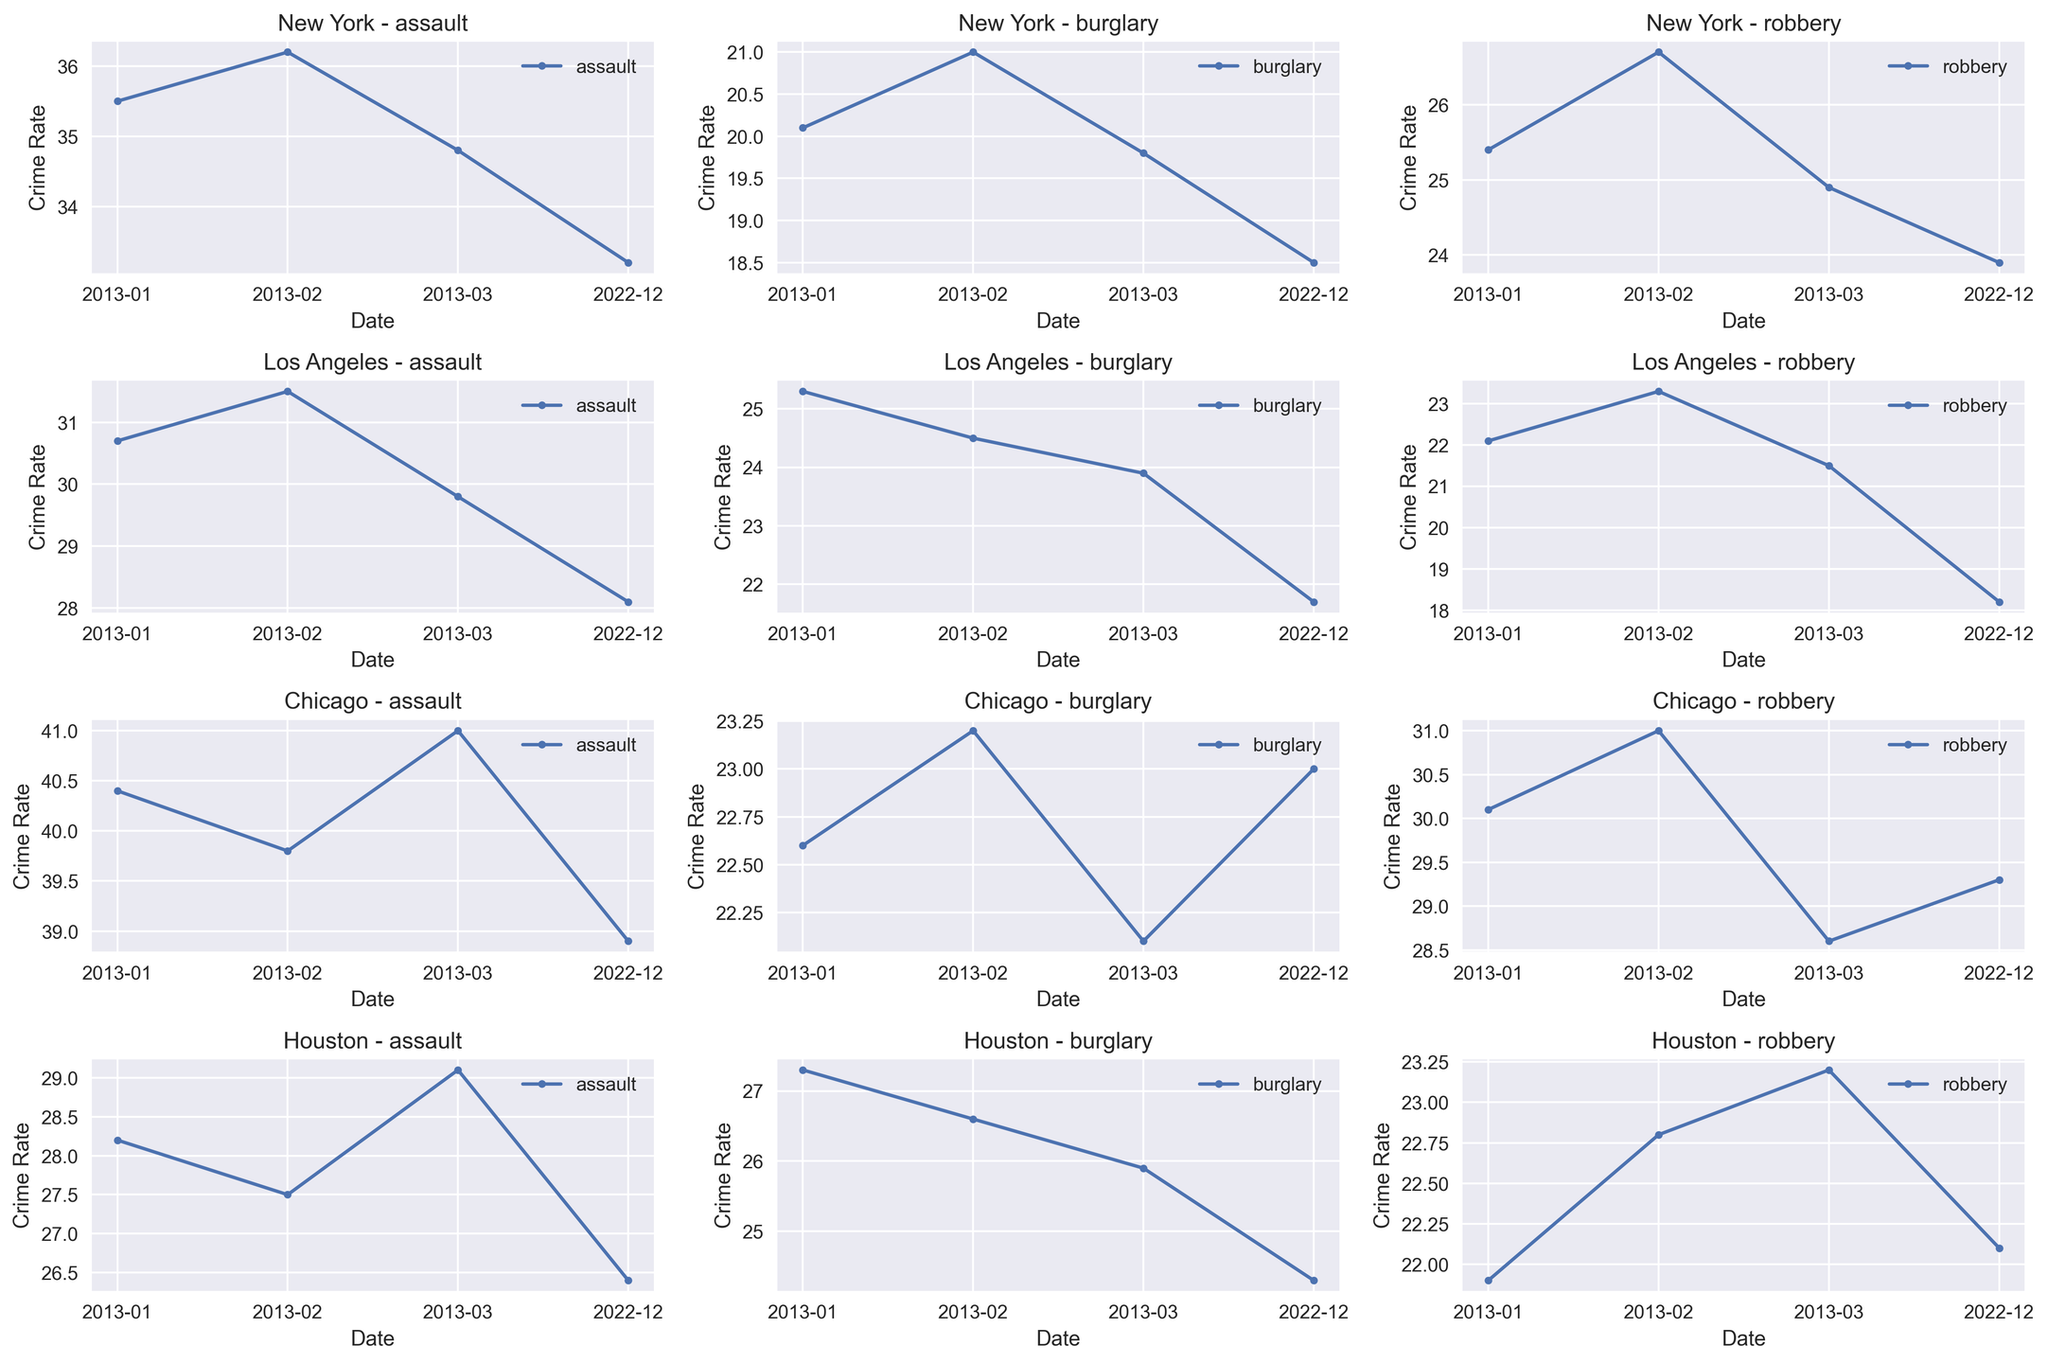What was the average robbery rate in New York throughout December 2022 and January 2013? First, find the robbery rates for New York in December 2022 and January 2013: 23.9 and 25.4 respectively. Add these values: 23.9 + 25.4 = 49.3. Then, find the average: 49.3 / 2 = 24.65
Answer: 24.65 Which city had the highest burglary rate in March 2013? Compare the burglary rates for each city in March 2013: New York (19.8), Los Angeles (23.9), Chicago (22.1), and Houston (25.9). Houston has the highest rate at 25.9
Answer: Houston Was the assault rate in Los Angeles in December 2022 higher or lower than in January 2013? Compare the assault rates in Los Angeles for December 2022 (28.1) and January 2013 (30.7). December 2022 has a lower assault rate than January 2013
Answer: Lower How did the burglary rate trend in Chicago from January 2013 to December 2022? Track the burglary rates in Chicago for January 2013 (22.6), March 2013 (22.1), and December 2022 (23.0). There is a slight increase by December 2022
Answer: Slight increase What is the total number of different crime types plotted for each city? Identify the crime types plotted: assault, burglary, robbery. Each city has these three types plotted
Answer: 3 Compare the assault rate trends in New York and Houston over the period 2013 to 2022. Observe the assault rate in New York from 35.5 (Jan 2013) to 33.2 (Dec 2022) - a slight decrease. Observe the assault rate in Houston from 28.2 (Jan 2013) to 26.4 (Dec 2022) - another slight decrease
Answer: Both cities show a slight decrease Which city had the most significant change in robbery rates from January 2013 to December 2022? Calculate the change in robbery rates for each city: New York (25.4 to 23.9, -1.5), Los Angeles (22.1 to 18.2, -3.9), Chicago (30.1 to 29.3, -0.8), Houston (21.9 to 22.1, +0.2). Los Angeles shows the most significant decrease
Answer: Los Angeles 